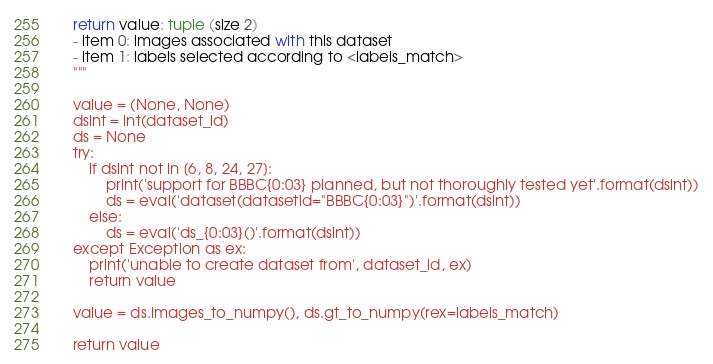Convert code to text. <code><loc_0><loc_0><loc_500><loc_500><_Python_>    return value: tuple (size 2)
    - item 0: images associated with this dataset
    - item 1: labels selected according to <labels_match>
    """

    value = (None, None)
    dsint = int(dataset_id)
    ds = None
    try:
        if dsint not in [6, 8, 24, 27]:
            print('support for BBBC{0:03} planned, but not thoroughly tested yet'.format(dsint))
            ds = eval('dataset(datasetid="BBBC{0:03}")'.format(dsint))
        else:
            ds = eval('ds_{0:03}()'.format(dsint))
    except Exception as ex:
        print('unable to create dataset from', dataset_id, ex)
        return value

    value = ds.images_to_numpy(), ds.gt_to_numpy(rex=labels_match)

    return value
</code> 